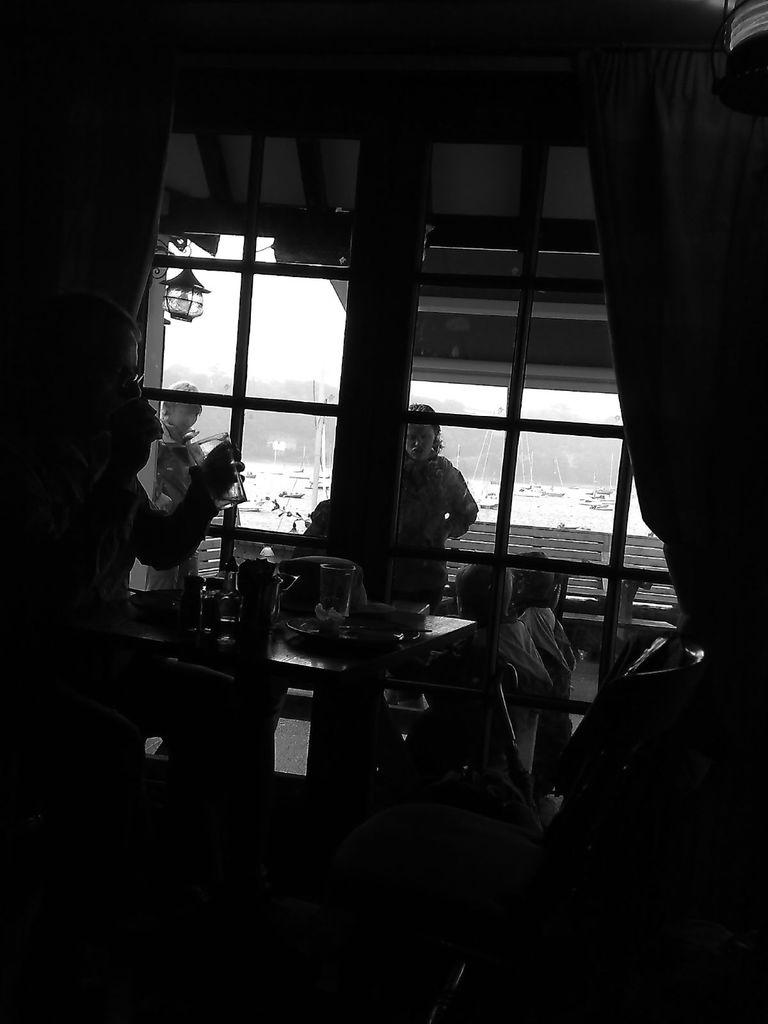What is the person in the image doing? The person is sitting on a chair in the image. Where is the person located in the image? The person is on the left side of the image. What is the person doing while sitting on the chair? The person is having some drinks. What objects can be seen on the table in the image? There are glasses on the table in the image. What type of skirt is the person wearing in the image? The provided facts do not mention any skirt, so we cannot determine the type of skirt the person is wearing. 